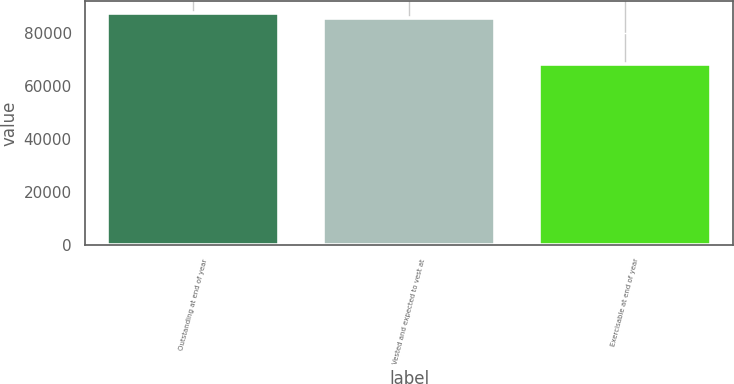<chart> <loc_0><loc_0><loc_500><loc_500><bar_chart><fcel>Outstanding at end of year<fcel>Vested and expected to vest at<fcel>Exercisable at end of year<nl><fcel>87820.9<fcel>85935<fcel>68437<nl></chart> 